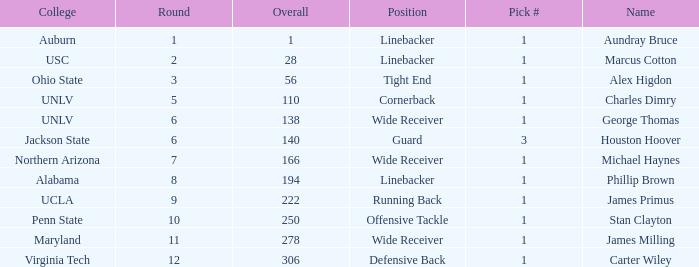What was the first Round with a Pick # greater than 1 and 140 Overall? None. 